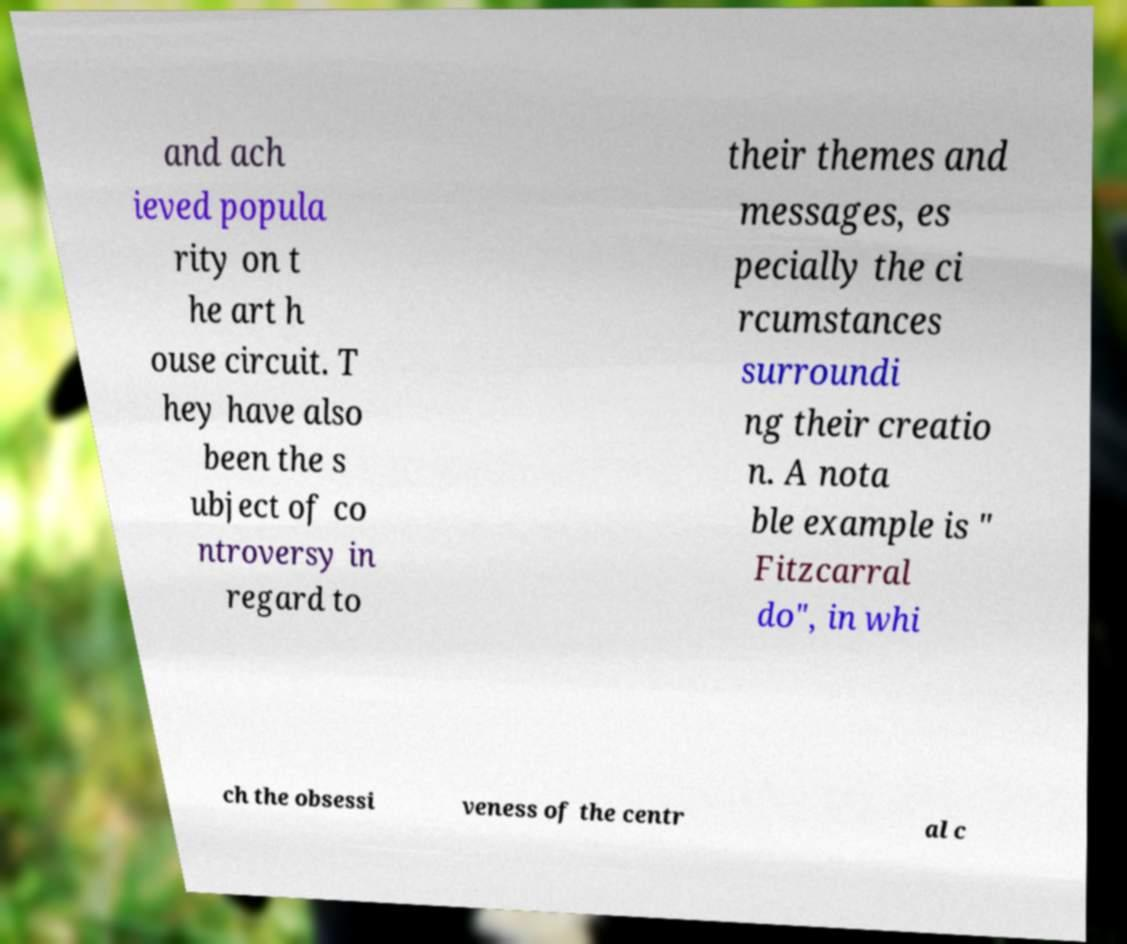There's text embedded in this image that I need extracted. Can you transcribe it verbatim? and ach ieved popula rity on t he art h ouse circuit. T hey have also been the s ubject of co ntroversy in regard to their themes and messages, es pecially the ci rcumstances surroundi ng their creatio n. A nota ble example is " Fitzcarral do", in whi ch the obsessi veness of the centr al c 